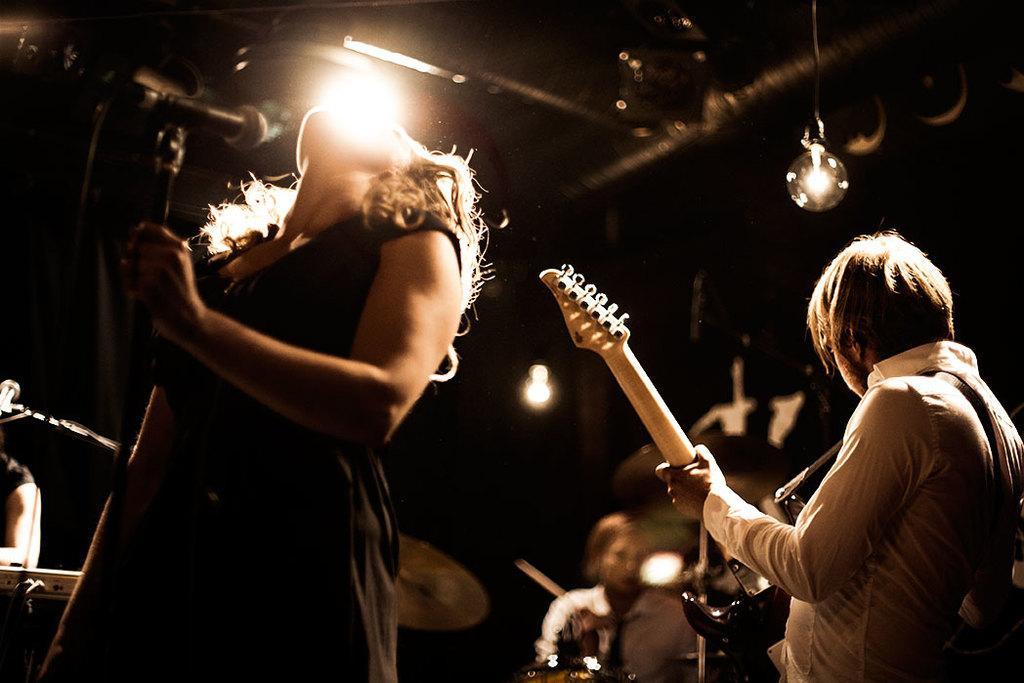Describe this image in one or two sentences. In the image there is a woman singing on mic and back side there is other persons playing guitar and other musical instruments and at the top there is light focusing them. 